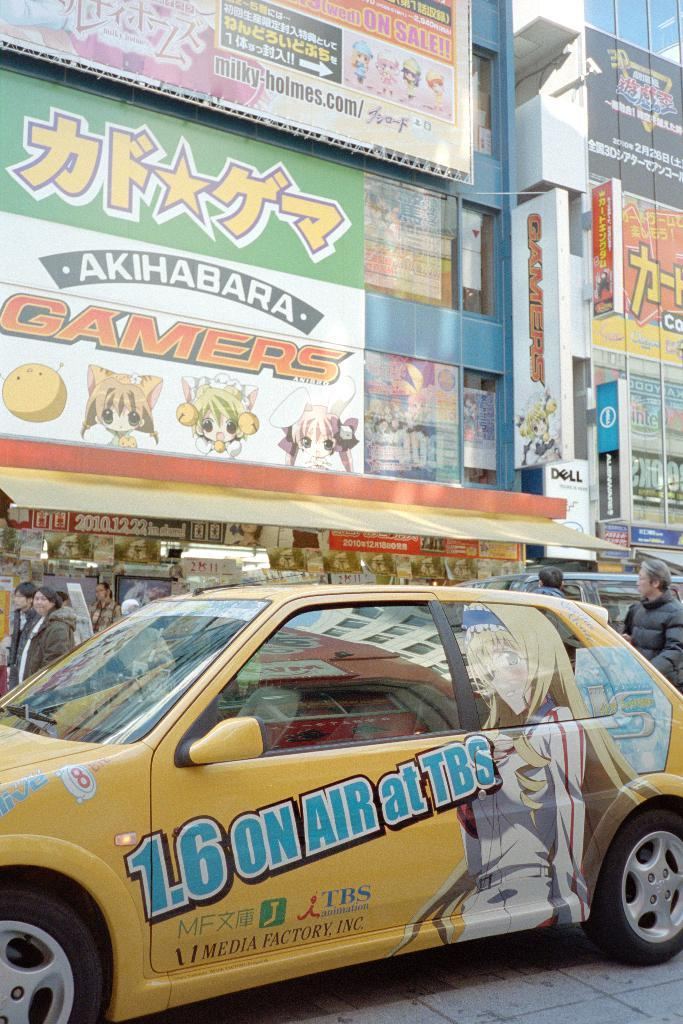<image>
Create a compact narrative representing the image presented. A yellow car is parked near a big sign that says gamers on it. 